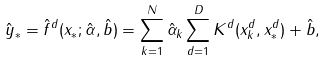<formula> <loc_0><loc_0><loc_500><loc_500>\hat { y } _ { \ast } = \hat { f } ^ { d } ( x _ { \ast } ; \hat { \alpha } , \hat { b } ) = \sum _ { k = 1 } ^ { N } \hat { \alpha } _ { k } \sum _ { d = 1 } ^ { D } K ^ { d } ( x _ { k } ^ { d } , x _ { \ast } ^ { d } ) + \hat { b } ,</formula> 